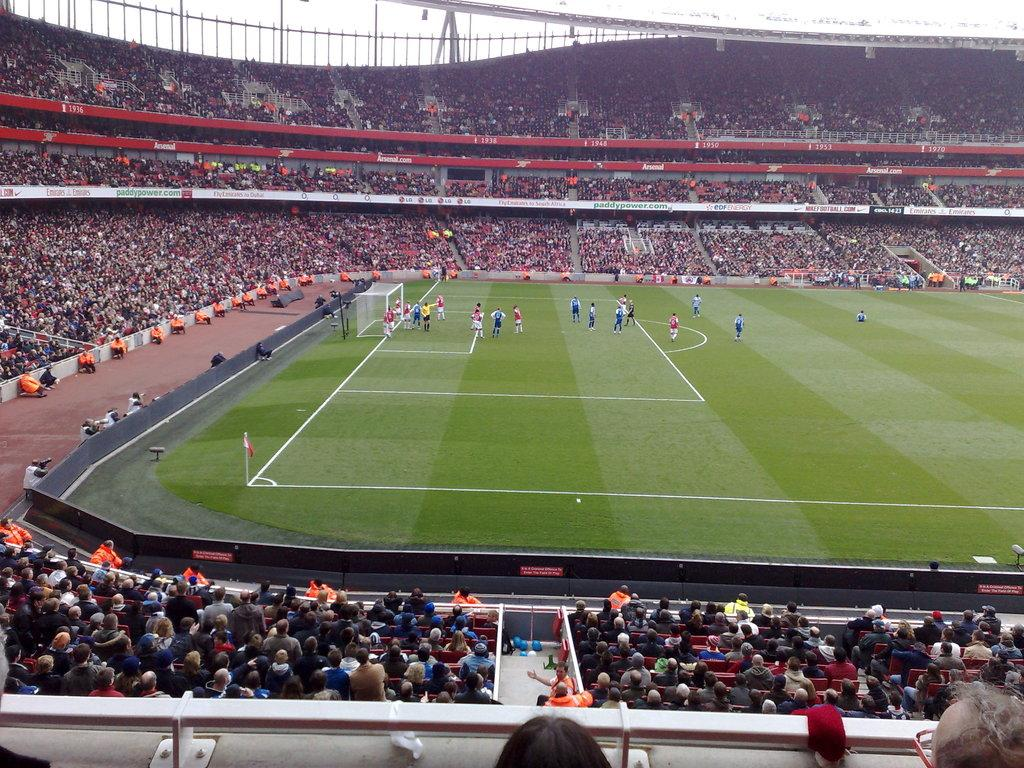Where was the image taken? The image was taken in a stadium. What activity is happening in the center of the image? People are playing a game in the center of the image. What is used to separate the teams or players in the game? There is a net in the image. Can you describe the people in the image? There is a crowd sitting in the image. What can be seen in the background of the image? The sky is visible in the background of the image. What type of cloth is draped over the form in the image? There is no form or cloth present in the image; it features a game being played in a stadium with a crowd and a net. 